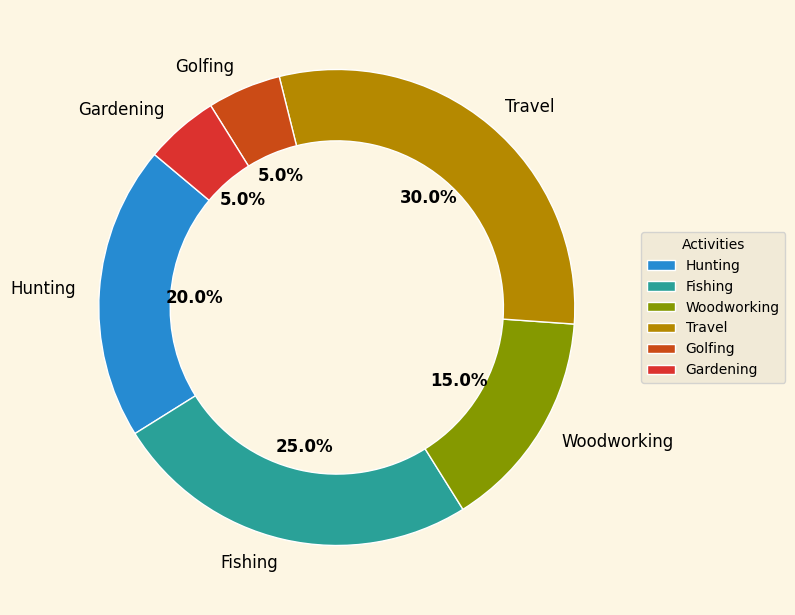What is the most preferred recreational activity post-retirement according to the pie chart? The activity with the highest percentage in the pie chart represents the most preferred recreational activity. Travel has the highest percentage at 30%.
Answer: Travel What is the combined percentage of people who prefer hunting and fishing? Add the percentages of hunting (20%) and fishing (25%). The combined percentage is 20% + 25% = 45%.
Answer: 45% Which activity has an equal percentage of preference as golfing? Compare the percentages of all activities to find one that matches the percentage for golfing (5%). Gardening also has a 5% preference.
Answer: Gardening By how much does the percentage of people who prefer travel exceed those who prefer woodworking? Subtract the percentage of woodworking (15%) from the percentage of travel (30%). The difference is 30% - 15% = 15%.
Answer: 15% How much higher is fishing compared to hunting in terms of preference percentage? Subtract the percentage of hunting (20%) from the percentage of fishing (25%). The difference is 25% - 20% = 5%.
Answer: 5% What is the average percentage of preference for gardening, golfing, and woodworking? Add the percentages for gardening (5%), golfing (5%), and woodworking (15%) and then divide by 3. The calculation is (5% + 5% + 15%) ÷ 3 = 25% ÷ 3 ≈ 8.33%.
Answer: 8.33% Which two activities sum up to 50% preference? Identify two activities whose percentages add up to 50%. Hunting (20%) and fishing (25%) sum up to 45%, but fishing (25%) and travel (30%) sum up to 55%, which is higher. There are no two activities that sum to exactly 50%. Hence, considering hunting and fishing (45%) or fishing and travel (55%) sum near this value can be the options.
Answer: No pair sums to exactly 50% Are there more people interested in travel or fishing? Compare the percentages for travel (30%) and fishing (25%). Travel has a higher percentage.
Answer: Travel Which activity has the least preference post-retirement? Identify the activity with the smallest percentage in the pie chart. Both golfing and gardening have the least preference at 5% each.
Answer: Golfing or Gardening What is the total percentage of people who prefer activities other than fishing? Subtract the percentage of fishing (25%) from 100%. The calculation is 100% - 25% = 75%.
Answer: 75% 